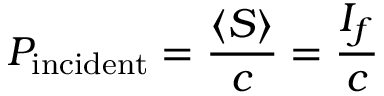Convert formula to latex. <formula><loc_0><loc_0><loc_500><loc_500>P _ { i n c i d e n t } = { \frac { \langle S \rangle } { c } } = { \frac { I _ { f } } { c } }</formula> 